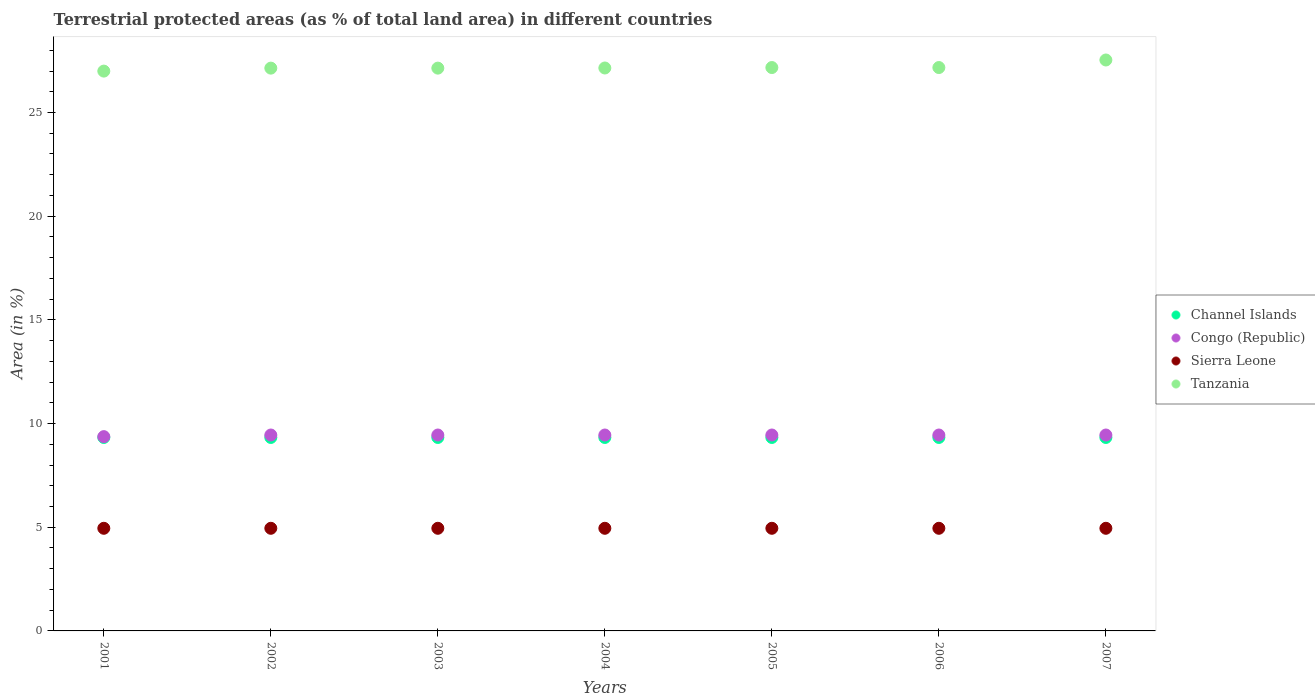How many different coloured dotlines are there?
Your answer should be very brief. 4. What is the percentage of terrestrial protected land in Tanzania in 2002?
Your response must be concise. 27.14. Across all years, what is the maximum percentage of terrestrial protected land in Sierra Leone?
Provide a short and direct response. 4.95. Across all years, what is the minimum percentage of terrestrial protected land in Tanzania?
Give a very brief answer. 27. In which year was the percentage of terrestrial protected land in Congo (Republic) maximum?
Provide a succinct answer. 2002. In which year was the percentage of terrestrial protected land in Tanzania minimum?
Ensure brevity in your answer.  2001. What is the total percentage of terrestrial protected land in Channel Islands in the graph?
Offer a terse response. 65.3. What is the difference between the percentage of terrestrial protected land in Tanzania in 2003 and that in 2004?
Your answer should be very brief. -0.01. What is the difference between the percentage of terrestrial protected land in Channel Islands in 2001 and the percentage of terrestrial protected land in Tanzania in 2007?
Your response must be concise. -18.2. What is the average percentage of terrestrial protected land in Congo (Republic) per year?
Your answer should be very brief. 9.44. In the year 2003, what is the difference between the percentage of terrestrial protected land in Congo (Republic) and percentage of terrestrial protected land in Channel Islands?
Your response must be concise. 0.12. What is the ratio of the percentage of terrestrial protected land in Sierra Leone in 2003 to that in 2006?
Keep it short and to the point. 1. What is the difference between the highest and the second highest percentage of terrestrial protected land in Channel Islands?
Make the answer very short. 0. What is the difference between the highest and the lowest percentage of terrestrial protected land in Tanzania?
Provide a succinct answer. 0.54. In how many years, is the percentage of terrestrial protected land in Tanzania greater than the average percentage of terrestrial protected land in Tanzania taken over all years?
Make the answer very short. 1. Is the sum of the percentage of terrestrial protected land in Congo (Republic) in 2001 and 2006 greater than the maximum percentage of terrestrial protected land in Sierra Leone across all years?
Keep it short and to the point. Yes. Is the percentage of terrestrial protected land in Channel Islands strictly greater than the percentage of terrestrial protected land in Tanzania over the years?
Your response must be concise. No. Is the percentage of terrestrial protected land in Channel Islands strictly less than the percentage of terrestrial protected land in Sierra Leone over the years?
Your answer should be compact. No. What is the difference between two consecutive major ticks on the Y-axis?
Make the answer very short. 5. Are the values on the major ticks of Y-axis written in scientific E-notation?
Your answer should be compact. No. Does the graph contain any zero values?
Your answer should be very brief. No. Where does the legend appear in the graph?
Give a very brief answer. Center right. How are the legend labels stacked?
Your answer should be compact. Vertical. What is the title of the graph?
Your response must be concise. Terrestrial protected areas (as % of total land area) in different countries. What is the label or title of the Y-axis?
Your answer should be very brief. Area (in %). What is the Area (in %) in Channel Islands in 2001?
Your answer should be compact. 9.33. What is the Area (in %) of Congo (Republic) in 2001?
Provide a short and direct response. 9.37. What is the Area (in %) in Sierra Leone in 2001?
Your answer should be compact. 4.95. What is the Area (in %) of Tanzania in 2001?
Keep it short and to the point. 27. What is the Area (in %) of Channel Islands in 2002?
Your answer should be very brief. 9.33. What is the Area (in %) in Congo (Republic) in 2002?
Offer a very short reply. 9.45. What is the Area (in %) of Sierra Leone in 2002?
Offer a very short reply. 4.95. What is the Area (in %) in Tanzania in 2002?
Ensure brevity in your answer.  27.14. What is the Area (in %) of Channel Islands in 2003?
Your answer should be compact. 9.33. What is the Area (in %) of Congo (Republic) in 2003?
Ensure brevity in your answer.  9.45. What is the Area (in %) in Sierra Leone in 2003?
Keep it short and to the point. 4.95. What is the Area (in %) in Tanzania in 2003?
Make the answer very short. 27.14. What is the Area (in %) of Channel Islands in 2004?
Your answer should be compact. 9.33. What is the Area (in %) in Congo (Republic) in 2004?
Ensure brevity in your answer.  9.45. What is the Area (in %) in Sierra Leone in 2004?
Offer a terse response. 4.95. What is the Area (in %) in Tanzania in 2004?
Your answer should be very brief. 27.15. What is the Area (in %) in Channel Islands in 2005?
Provide a succinct answer. 9.33. What is the Area (in %) of Congo (Republic) in 2005?
Keep it short and to the point. 9.45. What is the Area (in %) in Sierra Leone in 2005?
Make the answer very short. 4.95. What is the Area (in %) of Tanzania in 2005?
Offer a terse response. 27.17. What is the Area (in %) in Channel Islands in 2006?
Give a very brief answer. 9.33. What is the Area (in %) of Congo (Republic) in 2006?
Your answer should be very brief. 9.45. What is the Area (in %) in Sierra Leone in 2006?
Keep it short and to the point. 4.95. What is the Area (in %) in Tanzania in 2006?
Your answer should be very brief. 27.17. What is the Area (in %) in Channel Islands in 2007?
Offer a terse response. 9.33. What is the Area (in %) of Congo (Republic) in 2007?
Provide a short and direct response. 9.45. What is the Area (in %) of Sierra Leone in 2007?
Provide a succinct answer. 4.95. What is the Area (in %) of Tanzania in 2007?
Give a very brief answer. 27.53. Across all years, what is the maximum Area (in %) of Channel Islands?
Ensure brevity in your answer.  9.33. Across all years, what is the maximum Area (in %) in Congo (Republic)?
Provide a short and direct response. 9.45. Across all years, what is the maximum Area (in %) in Sierra Leone?
Keep it short and to the point. 4.95. Across all years, what is the maximum Area (in %) in Tanzania?
Provide a short and direct response. 27.53. Across all years, what is the minimum Area (in %) in Channel Islands?
Ensure brevity in your answer.  9.33. Across all years, what is the minimum Area (in %) of Congo (Republic)?
Make the answer very short. 9.37. Across all years, what is the minimum Area (in %) in Sierra Leone?
Offer a very short reply. 4.95. Across all years, what is the minimum Area (in %) of Tanzania?
Offer a terse response. 27. What is the total Area (in %) in Channel Islands in the graph?
Your answer should be very brief. 65.3. What is the total Area (in %) of Congo (Republic) in the graph?
Your answer should be very brief. 66.06. What is the total Area (in %) of Sierra Leone in the graph?
Your answer should be very brief. 34.65. What is the total Area (in %) of Tanzania in the graph?
Offer a very short reply. 190.3. What is the difference between the Area (in %) of Congo (Republic) in 2001 and that in 2002?
Your answer should be compact. -0.08. What is the difference between the Area (in %) in Sierra Leone in 2001 and that in 2002?
Make the answer very short. 0. What is the difference between the Area (in %) of Tanzania in 2001 and that in 2002?
Provide a succinct answer. -0.14. What is the difference between the Area (in %) of Congo (Republic) in 2001 and that in 2003?
Offer a very short reply. -0.08. What is the difference between the Area (in %) in Tanzania in 2001 and that in 2003?
Your response must be concise. -0.14. What is the difference between the Area (in %) in Congo (Republic) in 2001 and that in 2004?
Give a very brief answer. -0.08. What is the difference between the Area (in %) in Sierra Leone in 2001 and that in 2004?
Give a very brief answer. 0. What is the difference between the Area (in %) in Tanzania in 2001 and that in 2004?
Ensure brevity in your answer.  -0.15. What is the difference between the Area (in %) of Congo (Republic) in 2001 and that in 2005?
Make the answer very short. -0.08. What is the difference between the Area (in %) of Sierra Leone in 2001 and that in 2005?
Offer a very short reply. 0. What is the difference between the Area (in %) in Tanzania in 2001 and that in 2005?
Your response must be concise. -0.17. What is the difference between the Area (in %) of Channel Islands in 2001 and that in 2006?
Keep it short and to the point. 0. What is the difference between the Area (in %) of Congo (Republic) in 2001 and that in 2006?
Offer a terse response. -0.08. What is the difference between the Area (in %) of Tanzania in 2001 and that in 2006?
Offer a very short reply. -0.17. What is the difference between the Area (in %) of Channel Islands in 2001 and that in 2007?
Your answer should be very brief. 0. What is the difference between the Area (in %) of Congo (Republic) in 2001 and that in 2007?
Make the answer very short. -0.08. What is the difference between the Area (in %) of Tanzania in 2001 and that in 2007?
Offer a terse response. -0.54. What is the difference between the Area (in %) in Channel Islands in 2002 and that in 2003?
Make the answer very short. 0. What is the difference between the Area (in %) of Congo (Republic) in 2002 and that in 2003?
Offer a terse response. 0. What is the difference between the Area (in %) of Sierra Leone in 2002 and that in 2003?
Offer a very short reply. 0. What is the difference between the Area (in %) of Tanzania in 2002 and that in 2003?
Keep it short and to the point. 0. What is the difference between the Area (in %) of Sierra Leone in 2002 and that in 2004?
Provide a short and direct response. 0. What is the difference between the Area (in %) in Tanzania in 2002 and that in 2004?
Your response must be concise. -0.01. What is the difference between the Area (in %) of Channel Islands in 2002 and that in 2005?
Offer a very short reply. 0. What is the difference between the Area (in %) of Tanzania in 2002 and that in 2005?
Your response must be concise. -0.03. What is the difference between the Area (in %) of Congo (Republic) in 2002 and that in 2006?
Offer a very short reply. 0. What is the difference between the Area (in %) of Sierra Leone in 2002 and that in 2006?
Keep it short and to the point. 0. What is the difference between the Area (in %) in Tanzania in 2002 and that in 2006?
Your response must be concise. -0.03. What is the difference between the Area (in %) in Tanzania in 2002 and that in 2007?
Ensure brevity in your answer.  -0.39. What is the difference between the Area (in %) in Channel Islands in 2003 and that in 2004?
Offer a terse response. 0. What is the difference between the Area (in %) in Tanzania in 2003 and that in 2004?
Your response must be concise. -0.01. What is the difference between the Area (in %) in Sierra Leone in 2003 and that in 2005?
Provide a short and direct response. 0. What is the difference between the Area (in %) of Tanzania in 2003 and that in 2005?
Make the answer very short. -0.03. What is the difference between the Area (in %) of Congo (Republic) in 2003 and that in 2006?
Give a very brief answer. 0. What is the difference between the Area (in %) of Sierra Leone in 2003 and that in 2006?
Provide a short and direct response. 0. What is the difference between the Area (in %) in Tanzania in 2003 and that in 2006?
Offer a very short reply. -0.03. What is the difference between the Area (in %) in Congo (Republic) in 2003 and that in 2007?
Offer a terse response. -0. What is the difference between the Area (in %) in Tanzania in 2003 and that in 2007?
Your answer should be compact. -0.39. What is the difference between the Area (in %) in Tanzania in 2004 and that in 2005?
Give a very brief answer. -0.02. What is the difference between the Area (in %) in Sierra Leone in 2004 and that in 2006?
Provide a short and direct response. 0. What is the difference between the Area (in %) in Tanzania in 2004 and that in 2006?
Offer a terse response. -0.02. What is the difference between the Area (in %) in Channel Islands in 2004 and that in 2007?
Your response must be concise. 0. What is the difference between the Area (in %) in Tanzania in 2004 and that in 2007?
Your response must be concise. -0.39. What is the difference between the Area (in %) in Channel Islands in 2005 and that in 2006?
Your answer should be compact. 0. What is the difference between the Area (in %) of Congo (Republic) in 2005 and that in 2006?
Keep it short and to the point. 0. What is the difference between the Area (in %) in Sierra Leone in 2005 and that in 2006?
Keep it short and to the point. 0. What is the difference between the Area (in %) of Tanzania in 2005 and that in 2006?
Keep it short and to the point. 0. What is the difference between the Area (in %) in Tanzania in 2005 and that in 2007?
Offer a very short reply. -0.36. What is the difference between the Area (in %) of Channel Islands in 2006 and that in 2007?
Ensure brevity in your answer.  0. What is the difference between the Area (in %) of Congo (Republic) in 2006 and that in 2007?
Keep it short and to the point. -0. What is the difference between the Area (in %) of Tanzania in 2006 and that in 2007?
Your answer should be compact. -0.36. What is the difference between the Area (in %) in Channel Islands in 2001 and the Area (in %) in Congo (Republic) in 2002?
Your answer should be very brief. -0.12. What is the difference between the Area (in %) of Channel Islands in 2001 and the Area (in %) of Sierra Leone in 2002?
Ensure brevity in your answer.  4.38. What is the difference between the Area (in %) in Channel Islands in 2001 and the Area (in %) in Tanzania in 2002?
Give a very brief answer. -17.81. What is the difference between the Area (in %) in Congo (Republic) in 2001 and the Area (in %) in Sierra Leone in 2002?
Your answer should be very brief. 4.42. What is the difference between the Area (in %) of Congo (Republic) in 2001 and the Area (in %) of Tanzania in 2002?
Give a very brief answer. -17.77. What is the difference between the Area (in %) in Sierra Leone in 2001 and the Area (in %) in Tanzania in 2002?
Make the answer very short. -22.19. What is the difference between the Area (in %) of Channel Islands in 2001 and the Area (in %) of Congo (Republic) in 2003?
Your response must be concise. -0.12. What is the difference between the Area (in %) of Channel Islands in 2001 and the Area (in %) of Sierra Leone in 2003?
Your response must be concise. 4.38. What is the difference between the Area (in %) in Channel Islands in 2001 and the Area (in %) in Tanzania in 2003?
Provide a short and direct response. -17.81. What is the difference between the Area (in %) of Congo (Republic) in 2001 and the Area (in %) of Sierra Leone in 2003?
Offer a very short reply. 4.42. What is the difference between the Area (in %) of Congo (Republic) in 2001 and the Area (in %) of Tanzania in 2003?
Provide a succinct answer. -17.77. What is the difference between the Area (in %) of Sierra Leone in 2001 and the Area (in %) of Tanzania in 2003?
Your answer should be very brief. -22.19. What is the difference between the Area (in %) in Channel Islands in 2001 and the Area (in %) in Congo (Republic) in 2004?
Make the answer very short. -0.12. What is the difference between the Area (in %) of Channel Islands in 2001 and the Area (in %) of Sierra Leone in 2004?
Make the answer very short. 4.38. What is the difference between the Area (in %) in Channel Islands in 2001 and the Area (in %) in Tanzania in 2004?
Keep it short and to the point. -17.82. What is the difference between the Area (in %) of Congo (Republic) in 2001 and the Area (in %) of Sierra Leone in 2004?
Keep it short and to the point. 4.42. What is the difference between the Area (in %) in Congo (Republic) in 2001 and the Area (in %) in Tanzania in 2004?
Give a very brief answer. -17.78. What is the difference between the Area (in %) in Sierra Leone in 2001 and the Area (in %) in Tanzania in 2004?
Provide a succinct answer. -22.2. What is the difference between the Area (in %) in Channel Islands in 2001 and the Area (in %) in Congo (Republic) in 2005?
Offer a very short reply. -0.12. What is the difference between the Area (in %) of Channel Islands in 2001 and the Area (in %) of Sierra Leone in 2005?
Make the answer very short. 4.38. What is the difference between the Area (in %) of Channel Islands in 2001 and the Area (in %) of Tanzania in 2005?
Provide a succinct answer. -17.84. What is the difference between the Area (in %) of Congo (Republic) in 2001 and the Area (in %) of Sierra Leone in 2005?
Your answer should be compact. 4.42. What is the difference between the Area (in %) of Congo (Republic) in 2001 and the Area (in %) of Tanzania in 2005?
Provide a short and direct response. -17.8. What is the difference between the Area (in %) in Sierra Leone in 2001 and the Area (in %) in Tanzania in 2005?
Provide a short and direct response. -22.22. What is the difference between the Area (in %) in Channel Islands in 2001 and the Area (in %) in Congo (Republic) in 2006?
Your answer should be compact. -0.12. What is the difference between the Area (in %) in Channel Islands in 2001 and the Area (in %) in Sierra Leone in 2006?
Your answer should be compact. 4.38. What is the difference between the Area (in %) in Channel Islands in 2001 and the Area (in %) in Tanzania in 2006?
Offer a very short reply. -17.84. What is the difference between the Area (in %) of Congo (Republic) in 2001 and the Area (in %) of Sierra Leone in 2006?
Ensure brevity in your answer.  4.42. What is the difference between the Area (in %) of Congo (Republic) in 2001 and the Area (in %) of Tanzania in 2006?
Provide a short and direct response. -17.8. What is the difference between the Area (in %) in Sierra Leone in 2001 and the Area (in %) in Tanzania in 2006?
Make the answer very short. -22.22. What is the difference between the Area (in %) in Channel Islands in 2001 and the Area (in %) in Congo (Republic) in 2007?
Your answer should be very brief. -0.12. What is the difference between the Area (in %) in Channel Islands in 2001 and the Area (in %) in Sierra Leone in 2007?
Provide a succinct answer. 4.38. What is the difference between the Area (in %) of Channel Islands in 2001 and the Area (in %) of Tanzania in 2007?
Offer a terse response. -18.2. What is the difference between the Area (in %) in Congo (Republic) in 2001 and the Area (in %) in Sierra Leone in 2007?
Give a very brief answer. 4.42. What is the difference between the Area (in %) of Congo (Republic) in 2001 and the Area (in %) of Tanzania in 2007?
Offer a very short reply. -18.16. What is the difference between the Area (in %) of Sierra Leone in 2001 and the Area (in %) of Tanzania in 2007?
Provide a succinct answer. -22.58. What is the difference between the Area (in %) in Channel Islands in 2002 and the Area (in %) in Congo (Republic) in 2003?
Ensure brevity in your answer.  -0.12. What is the difference between the Area (in %) in Channel Islands in 2002 and the Area (in %) in Sierra Leone in 2003?
Your response must be concise. 4.38. What is the difference between the Area (in %) of Channel Islands in 2002 and the Area (in %) of Tanzania in 2003?
Provide a succinct answer. -17.81. What is the difference between the Area (in %) in Congo (Republic) in 2002 and the Area (in %) in Sierra Leone in 2003?
Offer a terse response. 4.5. What is the difference between the Area (in %) in Congo (Republic) in 2002 and the Area (in %) in Tanzania in 2003?
Offer a terse response. -17.69. What is the difference between the Area (in %) in Sierra Leone in 2002 and the Area (in %) in Tanzania in 2003?
Make the answer very short. -22.19. What is the difference between the Area (in %) of Channel Islands in 2002 and the Area (in %) of Congo (Republic) in 2004?
Offer a terse response. -0.12. What is the difference between the Area (in %) of Channel Islands in 2002 and the Area (in %) of Sierra Leone in 2004?
Offer a very short reply. 4.38. What is the difference between the Area (in %) in Channel Islands in 2002 and the Area (in %) in Tanzania in 2004?
Provide a succinct answer. -17.82. What is the difference between the Area (in %) of Congo (Republic) in 2002 and the Area (in %) of Sierra Leone in 2004?
Your answer should be compact. 4.5. What is the difference between the Area (in %) in Congo (Republic) in 2002 and the Area (in %) in Tanzania in 2004?
Your response must be concise. -17.7. What is the difference between the Area (in %) in Sierra Leone in 2002 and the Area (in %) in Tanzania in 2004?
Provide a succinct answer. -22.2. What is the difference between the Area (in %) in Channel Islands in 2002 and the Area (in %) in Congo (Republic) in 2005?
Make the answer very short. -0.12. What is the difference between the Area (in %) in Channel Islands in 2002 and the Area (in %) in Sierra Leone in 2005?
Make the answer very short. 4.38. What is the difference between the Area (in %) of Channel Islands in 2002 and the Area (in %) of Tanzania in 2005?
Make the answer very short. -17.84. What is the difference between the Area (in %) in Congo (Republic) in 2002 and the Area (in %) in Sierra Leone in 2005?
Offer a terse response. 4.5. What is the difference between the Area (in %) in Congo (Republic) in 2002 and the Area (in %) in Tanzania in 2005?
Your answer should be compact. -17.72. What is the difference between the Area (in %) in Sierra Leone in 2002 and the Area (in %) in Tanzania in 2005?
Your answer should be very brief. -22.22. What is the difference between the Area (in %) in Channel Islands in 2002 and the Area (in %) in Congo (Republic) in 2006?
Your answer should be compact. -0.12. What is the difference between the Area (in %) in Channel Islands in 2002 and the Area (in %) in Sierra Leone in 2006?
Offer a terse response. 4.38. What is the difference between the Area (in %) of Channel Islands in 2002 and the Area (in %) of Tanzania in 2006?
Offer a terse response. -17.84. What is the difference between the Area (in %) in Congo (Republic) in 2002 and the Area (in %) in Sierra Leone in 2006?
Offer a very short reply. 4.5. What is the difference between the Area (in %) of Congo (Republic) in 2002 and the Area (in %) of Tanzania in 2006?
Your response must be concise. -17.72. What is the difference between the Area (in %) of Sierra Leone in 2002 and the Area (in %) of Tanzania in 2006?
Provide a succinct answer. -22.22. What is the difference between the Area (in %) of Channel Islands in 2002 and the Area (in %) of Congo (Republic) in 2007?
Provide a succinct answer. -0.12. What is the difference between the Area (in %) of Channel Islands in 2002 and the Area (in %) of Sierra Leone in 2007?
Your answer should be very brief. 4.38. What is the difference between the Area (in %) in Channel Islands in 2002 and the Area (in %) in Tanzania in 2007?
Provide a succinct answer. -18.2. What is the difference between the Area (in %) in Congo (Republic) in 2002 and the Area (in %) in Sierra Leone in 2007?
Your answer should be compact. 4.5. What is the difference between the Area (in %) in Congo (Republic) in 2002 and the Area (in %) in Tanzania in 2007?
Offer a very short reply. -18.09. What is the difference between the Area (in %) in Sierra Leone in 2002 and the Area (in %) in Tanzania in 2007?
Offer a terse response. -22.58. What is the difference between the Area (in %) in Channel Islands in 2003 and the Area (in %) in Congo (Republic) in 2004?
Provide a short and direct response. -0.12. What is the difference between the Area (in %) of Channel Islands in 2003 and the Area (in %) of Sierra Leone in 2004?
Give a very brief answer. 4.38. What is the difference between the Area (in %) of Channel Islands in 2003 and the Area (in %) of Tanzania in 2004?
Provide a succinct answer. -17.82. What is the difference between the Area (in %) in Congo (Republic) in 2003 and the Area (in %) in Sierra Leone in 2004?
Provide a succinct answer. 4.5. What is the difference between the Area (in %) of Congo (Republic) in 2003 and the Area (in %) of Tanzania in 2004?
Your answer should be very brief. -17.7. What is the difference between the Area (in %) in Sierra Leone in 2003 and the Area (in %) in Tanzania in 2004?
Give a very brief answer. -22.2. What is the difference between the Area (in %) in Channel Islands in 2003 and the Area (in %) in Congo (Republic) in 2005?
Keep it short and to the point. -0.12. What is the difference between the Area (in %) of Channel Islands in 2003 and the Area (in %) of Sierra Leone in 2005?
Offer a very short reply. 4.38. What is the difference between the Area (in %) of Channel Islands in 2003 and the Area (in %) of Tanzania in 2005?
Give a very brief answer. -17.84. What is the difference between the Area (in %) in Congo (Republic) in 2003 and the Area (in %) in Sierra Leone in 2005?
Provide a short and direct response. 4.5. What is the difference between the Area (in %) in Congo (Republic) in 2003 and the Area (in %) in Tanzania in 2005?
Provide a succinct answer. -17.72. What is the difference between the Area (in %) in Sierra Leone in 2003 and the Area (in %) in Tanzania in 2005?
Your answer should be compact. -22.22. What is the difference between the Area (in %) in Channel Islands in 2003 and the Area (in %) in Congo (Republic) in 2006?
Offer a very short reply. -0.12. What is the difference between the Area (in %) in Channel Islands in 2003 and the Area (in %) in Sierra Leone in 2006?
Your answer should be very brief. 4.38. What is the difference between the Area (in %) of Channel Islands in 2003 and the Area (in %) of Tanzania in 2006?
Give a very brief answer. -17.84. What is the difference between the Area (in %) in Congo (Republic) in 2003 and the Area (in %) in Sierra Leone in 2006?
Provide a succinct answer. 4.5. What is the difference between the Area (in %) of Congo (Republic) in 2003 and the Area (in %) of Tanzania in 2006?
Ensure brevity in your answer.  -17.72. What is the difference between the Area (in %) in Sierra Leone in 2003 and the Area (in %) in Tanzania in 2006?
Offer a very short reply. -22.22. What is the difference between the Area (in %) of Channel Islands in 2003 and the Area (in %) of Congo (Republic) in 2007?
Provide a succinct answer. -0.12. What is the difference between the Area (in %) of Channel Islands in 2003 and the Area (in %) of Sierra Leone in 2007?
Offer a terse response. 4.38. What is the difference between the Area (in %) of Channel Islands in 2003 and the Area (in %) of Tanzania in 2007?
Offer a very short reply. -18.2. What is the difference between the Area (in %) in Congo (Republic) in 2003 and the Area (in %) in Sierra Leone in 2007?
Offer a very short reply. 4.5. What is the difference between the Area (in %) in Congo (Republic) in 2003 and the Area (in %) in Tanzania in 2007?
Offer a very short reply. -18.09. What is the difference between the Area (in %) of Sierra Leone in 2003 and the Area (in %) of Tanzania in 2007?
Your answer should be very brief. -22.58. What is the difference between the Area (in %) in Channel Islands in 2004 and the Area (in %) in Congo (Republic) in 2005?
Make the answer very short. -0.12. What is the difference between the Area (in %) in Channel Islands in 2004 and the Area (in %) in Sierra Leone in 2005?
Offer a terse response. 4.38. What is the difference between the Area (in %) in Channel Islands in 2004 and the Area (in %) in Tanzania in 2005?
Keep it short and to the point. -17.84. What is the difference between the Area (in %) in Congo (Republic) in 2004 and the Area (in %) in Sierra Leone in 2005?
Provide a succinct answer. 4.5. What is the difference between the Area (in %) in Congo (Republic) in 2004 and the Area (in %) in Tanzania in 2005?
Offer a terse response. -17.72. What is the difference between the Area (in %) in Sierra Leone in 2004 and the Area (in %) in Tanzania in 2005?
Give a very brief answer. -22.22. What is the difference between the Area (in %) of Channel Islands in 2004 and the Area (in %) of Congo (Republic) in 2006?
Provide a succinct answer. -0.12. What is the difference between the Area (in %) of Channel Islands in 2004 and the Area (in %) of Sierra Leone in 2006?
Make the answer very short. 4.38. What is the difference between the Area (in %) of Channel Islands in 2004 and the Area (in %) of Tanzania in 2006?
Provide a short and direct response. -17.84. What is the difference between the Area (in %) in Congo (Republic) in 2004 and the Area (in %) in Sierra Leone in 2006?
Give a very brief answer. 4.5. What is the difference between the Area (in %) in Congo (Republic) in 2004 and the Area (in %) in Tanzania in 2006?
Keep it short and to the point. -17.72. What is the difference between the Area (in %) in Sierra Leone in 2004 and the Area (in %) in Tanzania in 2006?
Give a very brief answer. -22.22. What is the difference between the Area (in %) in Channel Islands in 2004 and the Area (in %) in Congo (Republic) in 2007?
Give a very brief answer. -0.12. What is the difference between the Area (in %) of Channel Islands in 2004 and the Area (in %) of Sierra Leone in 2007?
Provide a succinct answer. 4.38. What is the difference between the Area (in %) of Channel Islands in 2004 and the Area (in %) of Tanzania in 2007?
Provide a short and direct response. -18.2. What is the difference between the Area (in %) in Congo (Republic) in 2004 and the Area (in %) in Sierra Leone in 2007?
Offer a terse response. 4.5. What is the difference between the Area (in %) of Congo (Republic) in 2004 and the Area (in %) of Tanzania in 2007?
Give a very brief answer. -18.09. What is the difference between the Area (in %) in Sierra Leone in 2004 and the Area (in %) in Tanzania in 2007?
Ensure brevity in your answer.  -22.58. What is the difference between the Area (in %) in Channel Islands in 2005 and the Area (in %) in Congo (Republic) in 2006?
Your response must be concise. -0.12. What is the difference between the Area (in %) in Channel Islands in 2005 and the Area (in %) in Sierra Leone in 2006?
Provide a short and direct response. 4.38. What is the difference between the Area (in %) of Channel Islands in 2005 and the Area (in %) of Tanzania in 2006?
Offer a very short reply. -17.84. What is the difference between the Area (in %) of Congo (Republic) in 2005 and the Area (in %) of Sierra Leone in 2006?
Offer a terse response. 4.5. What is the difference between the Area (in %) of Congo (Republic) in 2005 and the Area (in %) of Tanzania in 2006?
Keep it short and to the point. -17.72. What is the difference between the Area (in %) of Sierra Leone in 2005 and the Area (in %) of Tanzania in 2006?
Your answer should be very brief. -22.22. What is the difference between the Area (in %) in Channel Islands in 2005 and the Area (in %) in Congo (Republic) in 2007?
Keep it short and to the point. -0.12. What is the difference between the Area (in %) in Channel Islands in 2005 and the Area (in %) in Sierra Leone in 2007?
Ensure brevity in your answer.  4.38. What is the difference between the Area (in %) of Channel Islands in 2005 and the Area (in %) of Tanzania in 2007?
Provide a succinct answer. -18.2. What is the difference between the Area (in %) in Congo (Republic) in 2005 and the Area (in %) in Sierra Leone in 2007?
Provide a short and direct response. 4.5. What is the difference between the Area (in %) in Congo (Republic) in 2005 and the Area (in %) in Tanzania in 2007?
Make the answer very short. -18.09. What is the difference between the Area (in %) in Sierra Leone in 2005 and the Area (in %) in Tanzania in 2007?
Give a very brief answer. -22.58. What is the difference between the Area (in %) of Channel Islands in 2006 and the Area (in %) of Congo (Republic) in 2007?
Keep it short and to the point. -0.12. What is the difference between the Area (in %) in Channel Islands in 2006 and the Area (in %) in Sierra Leone in 2007?
Ensure brevity in your answer.  4.38. What is the difference between the Area (in %) of Channel Islands in 2006 and the Area (in %) of Tanzania in 2007?
Your answer should be compact. -18.2. What is the difference between the Area (in %) in Congo (Republic) in 2006 and the Area (in %) in Sierra Leone in 2007?
Provide a short and direct response. 4.5. What is the difference between the Area (in %) in Congo (Republic) in 2006 and the Area (in %) in Tanzania in 2007?
Offer a terse response. -18.09. What is the difference between the Area (in %) in Sierra Leone in 2006 and the Area (in %) in Tanzania in 2007?
Offer a very short reply. -22.58. What is the average Area (in %) in Channel Islands per year?
Make the answer very short. 9.33. What is the average Area (in %) of Congo (Republic) per year?
Your answer should be very brief. 9.44. What is the average Area (in %) of Sierra Leone per year?
Keep it short and to the point. 4.95. What is the average Area (in %) of Tanzania per year?
Your answer should be compact. 27.19. In the year 2001, what is the difference between the Area (in %) in Channel Islands and Area (in %) in Congo (Republic)?
Offer a terse response. -0.04. In the year 2001, what is the difference between the Area (in %) in Channel Islands and Area (in %) in Sierra Leone?
Your answer should be compact. 4.38. In the year 2001, what is the difference between the Area (in %) in Channel Islands and Area (in %) in Tanzania?
Keep it short and to the point. -17.67. In the year 2001, what is the difference between the Area (in %) of Congo (Republic) and Area (in %) of Sierra Leone?
Provide a short and direct response. 4.42. In the year 2001, what is the difference between the Area (in %) of Congo (Republic) and Area (in %) of Tanzania?
Ensure brevity in your answer.  -17.63. In the year 2001, what is the difference between the Area (in %) in Sierra Leone and Area (in %) in Tanzania?
Ensure brevity in your answer.  -22.05. In the year 2002, what is the difference between the Area (in %) in Channel Islands and Area (in %) in Congo (Republic)?
Your response must be concise. -0.12. In the year 2002, what is the difference between the Area (in %) of Channel Islands and Area (in %) of Sierra Leone?
Keep it short and to the point. 4.38. In the year 2002, what is the difference between the Area (in %) of Channel Islands and Area (in %) of Tanzania?
Provide a succinct answer. -17.81. In the year 2002, what is the difference between the Area (in %) of Congo (Republic) and Area (in %) of Sierra Leone?
Provide a short and direct response. 4.5. In the year 2002, what is the difference between the Area (in %) in Congo (Republic) and Area (in %) in Tanzania?
Make the answer very short. -17.69. In the year 2002, what is the difference between the Area (in %) in Sierra Leone and Area (in %) in Tanzania?
Provide a succinct answer. -22.19. In the year 2003, what is the difference between the Area (in %) of Channel Islands and Area (in %) of Congo (Republic)?
Ensure brevity in your answer.  -0.12. In the year 2003, what is the difference between the Area (in %) of Channel Islands and Area (in %) of Sierra Leone?
Your answer should be very brief. 4.38. In the year 2003, what is the difference between the Area (in %) in Channel Islands and Area (in %) in Tanzania?
Your response must be concise. -17.81. In the year 2003, what is the difference between the Area (in %) of Congo (Republic) and Area (in %) of Sierra Leone?
Provide a succinct answer. 4.5. In the year 2003, what is the difference between the Area (in %) of Congo (Republic) and Area (in %) of Tanzania?
Make the answer very short. -17.69. In the year 2003, what is the difference between the Area (in %) of Sierra Leone and Area (in %) of Tanzania?
Keep it short and to the point. -22.19. In the year 2004, what is the difference between the Area (in %) of Channel Islands and Area (in %) of Congo (Republic)?
Provide a succinct answer. -0.12. In the year 2004, what is the difference between the Area (in %) of Channel Islands and Area (in %) of Sierra Leone?
Your answer should be compact. 4.38. In the year 2004, what is the difference between the Area (in %) of Channel Islands and Area (in %) of Tanzania?
Offer a very short reply. -17.82. In the year 2004, what is the difference between the Area (in %) of Congo (Republic) and Area (in %) of Sierra Leone?
Keep it short and to the point. 4.5. In the year 2004, what is the difference between the Area (in %) of Congo (Republic) and Area (in %) of Tanzania?
Offer a very short reply. -17.7. In the year 2004, what is the difference between the Area (in %) in Sierra Leone and Area (in %) in Tanzania?
Your answer should be compact. -22.2. In the year 2005, what is the difference between the Area (in %) in Channel Islands and Area (in %) in Congo (Republic)?
Give a very brief answer. -0.12. In the year 2005, what is the difference between the Area (in %) in Channel Islands and Area (in %) in Sierra Leone?
Ensure brevity in your answer.  4.38. In the year 2005, what is the difference between the Area (in %) in Channel Islands and Area (in %) in Tanzania?
Offer a very short reply. -17.84. In the year 2005, what is the difference between the Area (in %) in Congo (Republic) and Area (in %) in Sierra Leone?
Keep it short and to the point. 4.5. In the year 2005, what is the difference between the Area (in %) in Congo (Republic) and Area (in %) in Tanzania?
Your response must be concise. -17.72. In the year 2005, what is the difference between the Area (in %) in Sierra Leone and Area (in %) in Tanzania?
Your answer should be compact. -22.22. In the year 2006, what is the difference between the Area (in %) in Channel Islands and Area (in %) in Congo (Republic)?
Offer a very short reply. -0.12. In the year 2006, what is the difference between the Area (in %) in Channel Islands and Area (in %) in Sierra Leone?
Keep it short and to the point. 4.38. In the year 2006, what is the difference between the Area (in %) of Channel Islands and Area (in %) of Tanzania?
Your answer should be very brief. -17.84. In the year 2006, what is the difference between the Area (in %) in Congo (Republic) and Area (in %) in Sierra Leone?
Keep it short and to the point. 4.5. In the year 2006, what is the difference between the Area (in %) in Congo (Republic) and Area (in %) in Tanzania?
Provide a short and direct response. -17.72. In the year 2006, what is the difference between the Area (in %) of Sierra Leone and Area (in %) of Tanzania?
Make the answer very short. -22.22. In the year 2007, what is the difference between the Area (in %) of Channel Islands and Area (in %) of Congo (Republic)?
Your answer should be very brief. -0.12. In the year 2007, what is the difference between the Area (in %) in Channel Islands and Area (in %) in Sierra Leone?
Your response must be concise. 4.38. In the year 2007, what is the difference between the Area (in %) of Channel Islands and Area (in %) of Tanzania?
Keep it short and to the point. -18.2. In the year 2007, what is the difference between the Area (in %) in Congo (Republic) and Area (in %) in Sierra Leone?
Offer a terse response. 4.5. In the year 2007, what is the difference between the Area (in %) of Congo (Republic) and Area (in %) of Tanzania?
Give a very brief answer. -18.09. In the year 2007, what is the difference between the Area (in %) in Sierra Leone and Area (in %) in Tanzania?
Keep it short and to the point. -22.58. What is the ratio of the Area (in %) of Channel Islands in 2001 to that in 2002?
Your answer should be very brief. 1. What is the ratio of the Area (in %) of Tanzania in 2001 to that in 2002?
Offer a very short reply. 0.99. What is the ratio of the Area (in %) of Channel Islands in 2001 to that in 2003?
Ensure brevity in your answer.  1. What is the ratio of the Area (in %) of Sierra Leone in 2001 to that in 2003?
Your answer should be very brief. 1. What is the ratio of the Area (in %) of Tanzania in 2001 to that in 2003?
Offer a terse response. 0.99. What is the ratio of the Area (in %) of Congo (Republic) in 2001 to that in 2004?
Give a very brief answer. 0.99. What is the ratio of the Area (in %) in Sierra Leone in 2001 to that in 2004?
Your answer should be very brief. 1. What is the ratio of the Area (in %) of Tanzania in 2001 to that in 2004?
Your answer should be very brief. 0.99. What is the ratio of the Area (in %) in Channel Islands in 2001 to that in 2005?
Offer a very short reply. 1. What is the ratio of the Area (in %) of Tanzania in 2001 to that in 2005?
Provide a succinct answer. 0.99. What is the ratio of the Area (in %) of Channel Islands in 2001 to that in 2006?
Provide a short and direct response. 1. What is the ratio of the Area (in %) of Congo (Republic) in 2001 to that in 2006?
Your answer should be compact. 0.99. What is the ratio of the Area (in %) of Sierra Leone in 2001 to that in 2006?
Give a very brief answer. 1. What is the ratio of the Area (in %) in Tanzania in 2001 to that in 2006?
Ensure brevity in your answer.  0.99. What is the ratio of the Area (in %) of Tanzania in 2001 to that in 2007?
Ensure brevity in your answer.  0.98. What is the ratio of the Area (in %) in Sierra Leone in 2002 to that in 2003?
Offer a very short reply. 1. What is the ratio of the Area (in %) in Channel Islands in 2002 to that in 2004?
Your response must be concise. 1. What is the ratio of the Area (in %) in Sierra Leone in 2002 to that in 2004?
Your answer should be compact. 1. What is the ratio of the Area (in %) in Congo (Republic) in 2002 to that in 2005?
Your answer should be very brief. 1. What is the ratio of the Area (in %) in Sierra Leone in 2002 to that in 2005?
Your answer should be compact. 1. What is the ratio of the Area (in %) in Channel Islands in 2002 to that in 2006?
Offer a terse response. 1. What is the ratio of the Area (in %) of Congo (Republic) in 2002 to that in 2006?
Make the answer very short. 1. What is the ratio of the Area (in %) in Tanzania in 2002 to that in 2006?
Give a very brief answer. 1. What is the ratio of the Area (in %) in Congo (Republic) in 2002 to that in 2007?
Give a very brief answer. 1. What is the ratio of the Area (in %) in Tanzania in 2002 to that in 2007?
Make the answer very short. 0.99. What is the ratio of the Area (in %) in Congo (Republic) in 2003 to that in 2004?
Keep it short and to the point. 1. What is the ratio of the Area (in %) in Channel Islands in 2003 to that in 2005?
Offer a very short reply. 1. What is the ratio of the Area (in %) of Channel Islands in 2003 to that in 2006?
Ensure brevity in your answer.  1. What is the ratio of the Area (in %) in Congo (Republic) in 2003 to that in 2006?
Make the answer very short. 1. What is the ratio of the Area (in %) in Tanzania in 2003 to that in 2006?
Keep it short and to the point. 1. What is the ratio of the Area (in %) in Channel Islands in 2003 to that in 2007?
Give a very brief answer. 1. What is the ratio of the Area (in %) of Tanzania in 2003 to that in 2007?
Ensure brevity in your answer.  0.99. What is the ratio of the Area (in %) of Channel Islands in 2004 to that in 2006?
Provide a short and direct response. 1. What is the ratio of the Area (in %) in Sierra Leone in 2004 to that in 2006?
Offer a very short reply. 1. What is the ratio of the Area (in %) in Channel Islands in 2004 to that in 2007?
Make the answer very short. 1. What is the ratio of the Area (in %) of Channel Islands in 2005 to that in 2006?
Make the answer very short. 1. What is the ratio of the Area (in %) in Congo (Republic) in 2005 to that in 2006?
Your answer should be compact. 1. What is the ratio of the Area (in %) in Sierra Leone in 2005 to that in 2006?
Make the answer very short. 1. What is the ratio of the Area (in %) in Congo (Republic) in 2005 to that in 2007?
Provide a succinct answer. 1. What is the ratio of the Area (in %) of Tanzania in 2005 to that in 2007?
Give a very brief answer. 0.99. What is the ratio of the Area (in %) in Channel Islands in 2006 to that in 2007?
Provide a succinct answer. 1. What is the ratio of the Area (in %) of Sierra Leone in 2006 to that in 2007?
Your response must be concise. 1. What is the difference between the highest and the second highest Area (in %) in Congo (Republic)?
Your answer should be compact. 0. What is the difference between the highest and the second highest Area (in %) of Tanzania?
Offer a terse response. 0.36. What is the difference between the highest and the lowest Area (in %) in Channel Islands?
Make the answer very short. 0. What is the difference between the highest and the lowest Area (in %) in Congo (Republic)?
Make the answer very short. 0.08. What is the difference between the highest and the lowest Area (in %) of Sierra Leone?
Offer a very short reply. 0. What is the difference between the highest and the lowest Area (in %) of Tanzania?
Provide a short and direct response. 0.54. 